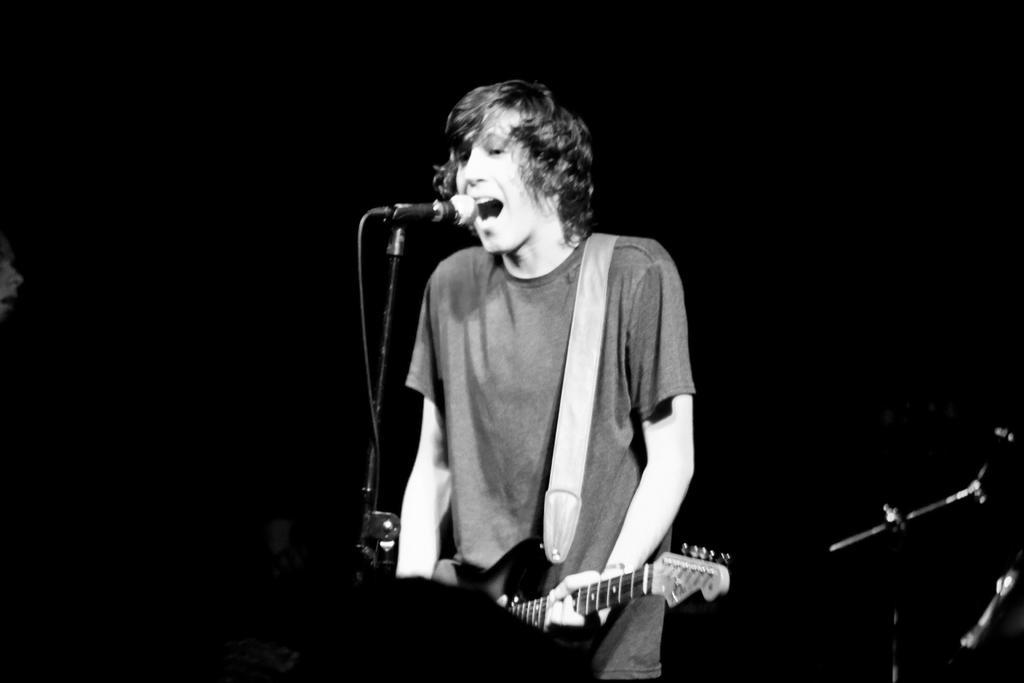Please provide a concise description of this image. in the picture a person is standing in front of a microphone catching a guitar and singing. 